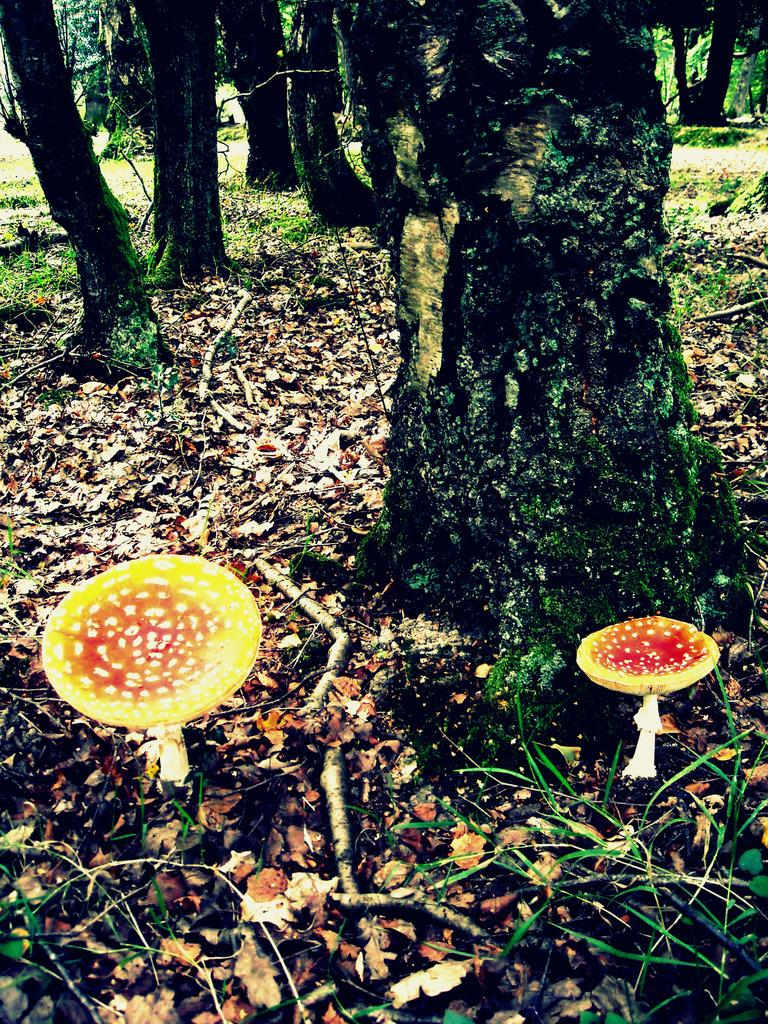What types of plants can be seen in the foreground of the image? There are mushrooms and grass in the foreground of the image. What else can be found on the ground in the foreground of the image? There are sticks and dried leaves on the ground in the foreground of the image. What is visible in the background of the image? There are trees in the background of the image. What type of wool can be seen on the trees in the image? There is no wool present on the trees in the image; it features mushrooms, grass, sticks, dried leaves, and trees. How does the beginner learn to identify the mushrooms in the image? The image does not provide any information on how to identify mushrooms or teach beginners; it simply displays the mushrooms, grass, sticks, dried leaves, and trees. 